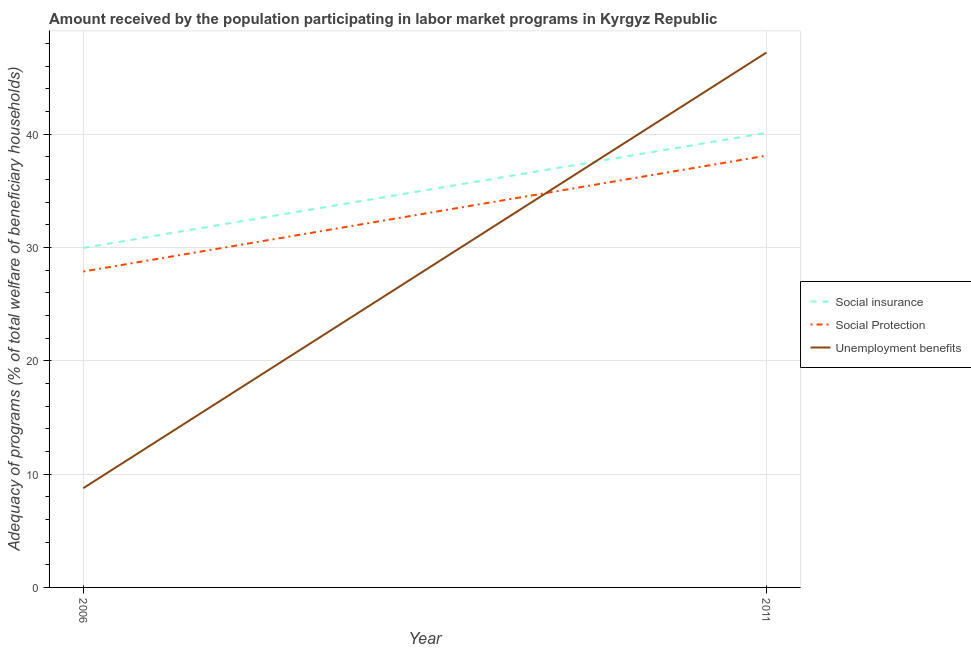How many different coloured lines are there?
Your answer should be compact. 3. Does the line corresponding to amount received by the population participating in social insurance programs intersect with the line corresponding to amount received by the population participating in unemployment benefits programs?
Provide a succinct answer. Yes. Is the number of lines equal to the number of legend labels?
Provide a short and direct response. Yes. What is the amount received by the population participating in social insurance programs in 2011?
Ensure brevity in your answer.  40.12. Across all years, what is the maximum amount received by the population participating in social insurance programs?
Your answer should be compact. 40.12. Across all years, what is the minimum amount received by the population participating in social protection programs?
Give a very brief answer. 27.88. What is the total amount received by the population participating in social protection programs in the graph?
Your response must be concise. 65.98. What is the difference between the amount received by the population participating in social insurance programs in 2006 and that in 2011?
Your response must be concise. -10.16. What is the difference between the amount received by the population participating in social protection programs in 2011 and the amount received by the population participating in unemployment benefits programs in 2006?
Make the answer very short. 29.34. What is the average amount received by the population participating in social insurance programs per year?
Keep it short and to the point. 35.04. In the year 2006, what is the difference between the amount received by the population participating in unemployment benefits programs and amount received by the population participating in social protection programs?
Your answer should be very brief. -19.12. What is the ratio of the amount received by the population participating in unemployment benefits programs in 2006 to that in 2011?
Offer a very short reply. 0.19. Is it the case that in every year, the sum of the amount received by the population participating in social insurance programs and amount received by the population participating in social protection programs is greater than the amount received by the population participating in unemployment benefits programs?
Offer a terse response. Yes. How many lines are there?
Offer a very short reply. 3. How many years are there in the graph?
Offer a very short reply. 2. What is the difference between two consecutive major ticks on the Y-axis?
Offer a very short reply. 10. Does the graph contain any zero values?
Keep it short and to the point. No. Does the graph contain grids?
Your answer should be compact. Yes. Where does the legend appear in the graph?
Your answer should be very brief. Center right. How are the legend labels stacked?
Offer a terse response. Vertical. What is the title of the graph?
Your response must be concise. Amount received by the population participating in labor market programs in Kyrgyz Republic. What is the label or title of the X-axis?
Make the answer very short. Year. What is the label or title of the Y-axis?
Your answer should be very brief. Adequacy of programs (% of total welfare of beneficiary households). What is the Adequacy of programs (% of total welfare of beneficiary households) in Social insurance in 2006?
Offer a terse response. 29.96. What is the Adequacy of programs (% of total welfare of beneficiary households) in Social Protection in 2006?
Offer a very short reply. 27.88. What is the Adequacy of programs (% of total welfare of beneficiary households) in Unemployment benefits in 2006?
Your answer should be compact. 8.76. What is the Adequacy of programs (% of total welfare of beneficiary households) of Social insurance in 2011?
Provide a succinct answer. 40.12. What is the Adequacy of programs (% of total welfare of beneficiary households) of Social Protection in 2011?
Your answer should be compact. 38.1. What is the Adequacy of programs (% of total welfare of beneficiary households) in Unemployment benefits in 2011?
Provide a short and direct response. 47.19. Across all years, what is the maximum Adequacy of programs (% of total welfare of beneficiary households) of Social insurance?
Give a very brief answer. 40.12. Across all years, what is the maximum Adequacy of programs (% of total welfare of beneficiary households) of Social Protection?
Provide a succinct answer. 38.1. Across all years, what is the maximum Adequacy of programs (% of total welfare of beneficiary households) in Unemployment benefits?
Your answer should be very brief. 47.19. Across all years, what is the minimum Adequacy of programs (% of total welfare of beneficiary households) of Social insurance?
Give a very brief answer. 29.96. Across all years, what is the minimum Adequacy of programs (% of total welfare of beneficiary households) of Social Protection?
Provide a succinct answer. 27.88. Across all years, what is the minimum Adequacy of programs (% of total welfare of beneficiary households) in Unemployment benefits?
Ensure brevity in your answer.  8.76. What is the total Adequacy of programs (% of total welfare of beneficiary households) of Social insurance in the graph?
Offer a very short reply. 70.07. What is the total Adequacy of programs (% of total welfare of beneficiary households) of Social Protection in the graph?
Provide a short and direct response. 65.98. What is the total Adequacy of programs (% of total welfare of beneficiary households) of Unemployment benefits in the graph?
Keep it short and to the point. 55.95. What is the difference between the Adequacy of programs (% of total welfare of beneficiary households) in Social insurance in 2006 and that in 2011?
Ensure brevity in your answer.  -10.16. What is the difference between the Adequacy of programs (% of total welfare of beneficiary households) of Social Protection in 2006 and that in 2011?
Your answer should be very brief. -10.22. What is the difference between the Adequacy of programs (% of total welfare of beneficiary households) in Unemployment benefits in 2006 and that in 2011?
Offer a terse response. -38.43. What is the difference between the Adequacy of programs (% of total welfare of beneficiary households) in Social insurance in 2006 and the Adequacy of programs (% of total welfare of beneficiary households) in Social Protection in 2011?
Make the answer very short. -8.14. What is the difference between the Adequacy of programs (% of total welfare of beneficiary households) of Social insurance in 2006 and the Adequacy of programs (% of total welfare of beneficiary households) of Unemployment benefits in 2011?
Provide a short and direct response. -17.24. What is the difference between the Adequacy of programs (% of total welfare of beneficiary households) in Social Protection in 2006 and the Adequacy of programs (% of total welfare of beneficiary households) in Unemployment benefits in 2011?
Your answer should be compact. -19.31. What is the average Adequacy of programs (% of total welfare of beneficiary households) in Social insurance per year?
Provide a succinct answer. 35.04. What is the average Adequacy of programs (% of total welfare of beneficiary households) in Social Protection per year?
Offer a very short reply. 32.99. What is the average Adequacy of programs (% of total welfare of beneficiary households) of Unemployment benefits per year?
Your answer should be very brief. 27.98. In the year 2006, what is the difference between the Adequacy of programs (% of total welfare of beneficiary households) in Social insurance and Adequacy of programs (% of total welfare of beneficiary households) in Social Protection?
Ensure brevity in your answer.  2.08. In the year 2006, what is the difference between the Adequacy of programs (% of total welfare of beneficiary households) in Social insurance and Adequacy of programs (% of total welfare of beneficiary households) in Unemployment benefits?
Offer a terse response. 21.2. In the year 2006, what is the difference between the Adequacy of programs (% of total welfare of beneficiary households) in Social Protection and Adequacy of programs (% of total welfare of beneficiary households) in Unemployment benefits?
Provide a short and direct response. 19.12. In the year 2011, what is the difference between the Adequacy of programs (% of total welfare of beneficiary households) of Social insurance and Adequacy of programs (% of total welfare of beneficiary households) of Social Protection?
Ensure brevity in your answer.  2.02. In the year 2011, what is the difference between the Adequacy of programs (% of total welfare of beneficiary households) in Social insurance and Adequacy of programs (% of total welfare of beneficiary households) in Unemployment benefits?
Offer a very short reply. -7.08. In the year 2011, what is the difference between the Adequacy of programs (% of total welfare of beneficiary households) in Social Protection and Adequacy of programs (% of total welfare of beneficiary households) in Unemployment benefits?
Ensure brevity in your answer.  -9.09. What is the ratio of the Adequacy of programs (% of total welfare of beneficiary households) in Social insurance in 2006 to that in 2011?
Make the answer very short. 0.75. What is the ratio of the Adequacy of programs (% of total welfare of beneficiary households) in Social Protection in 2006 to that in 2011?
Your answer should be compact. 0.73. What is the ratio of the Adequacy of programs (% of total welfare of beneficiary households) of Unemployment benefits in 2006 to that in 2011?
Your response must be concise. 0.19. What is the difference between the highest and the second highest Adequacy of programs (% of total welfare of beneficiary households) in Social insurance?
Your response must be concise. 10.16. What is the difference between the highest and the second highest Adequacy of programs (% of total welfare of beneficiary households) of Social Protection?
Your answer should be very brief. 10.22. What is the difference between the highest and the second highest Adequacy of programs (% of total welfare of beneficiary households) in Unemployment benefits?
Provide a short and direct response. 38.43. What is the difference between the highest and the lowest Adequacy of programs (% of total welfare of beneficiary households) of Social insurance?
Give a very brief answer. 10.16. What is the difference between the highest and the lowest Adequacy of programs (% of total welfare of beneficiary households) of Social Protection?
Your answer should be very brief. 10.22. What is the difference between the highest and the lowest Adequacy of programs (% of total welfare of beneficiary households) in Unemployment benefits?
Offer a very short reply. 38.43. 